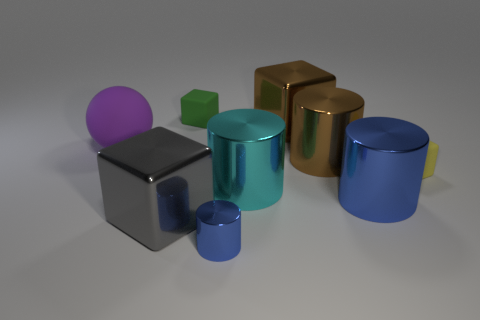Is there anything else that is the same size as the purple rubber sphere?
Offer a very short reply. Yes. What number of things are either tiny green shiny balls or objects in front of the ball?
Provide a succinct answer. 6. There is a blue metal cylinder left of the cyan thing; is it the same size as the gray block on the left side of the brown cylinder?
Your response must be concise. No. What number of other objects are there of the same color as the matte ball?
Make the answer very short. 0. There is a cyan object; is its size the same as the gray metal cube behind the small blue shiny object?
Your response must be concise. Yes. What size is the matte cube that is behind the big cube behind the cyan metal thing?
Provide a succinct answer. Small. What color is the other metallic object that is the same shape as the large gray metal thing?
Give a very brief answer. Brown. Do the yellow matte block and the cyan metallic object have the same size?
Your answer should be very brief. No. Are there the same number of green rubber things to the right of the cyan cylinder and purple matte things?
Your response must be concise. No. Are there any tiny yellow matte blocks that are to the left of the big metal cube in front of the big blue cylinder?
Provide a short and direct response. No. 